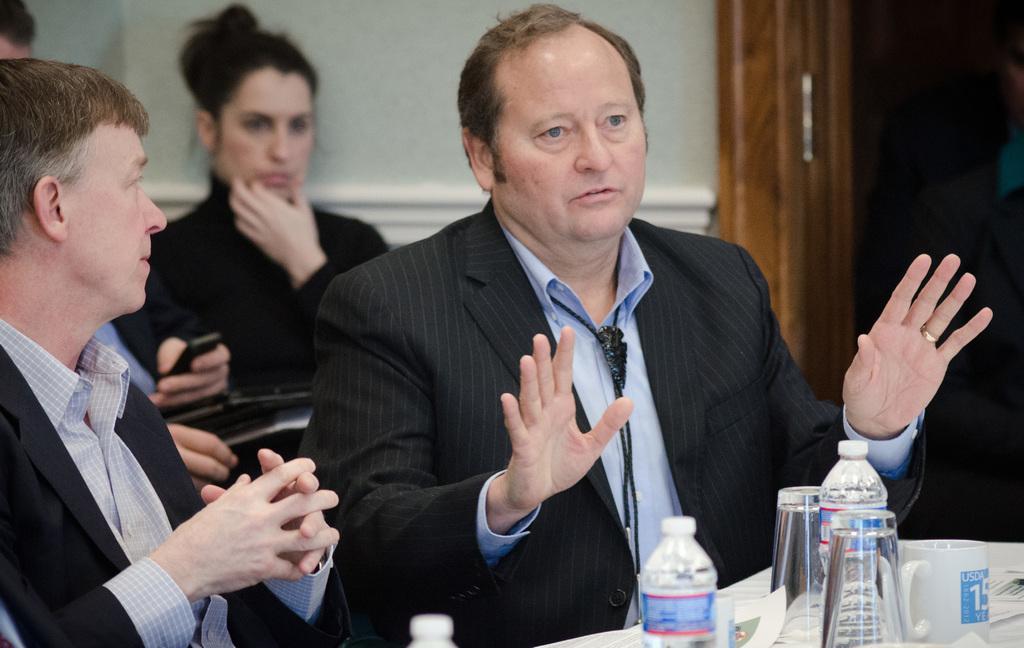Describe this image in one or two sentences. In this image there are two persons sitting on chairs, in front of them there are glasses, a bottle of water and a cup on the table, behind them there is a woman, beside the man there is an open door. 